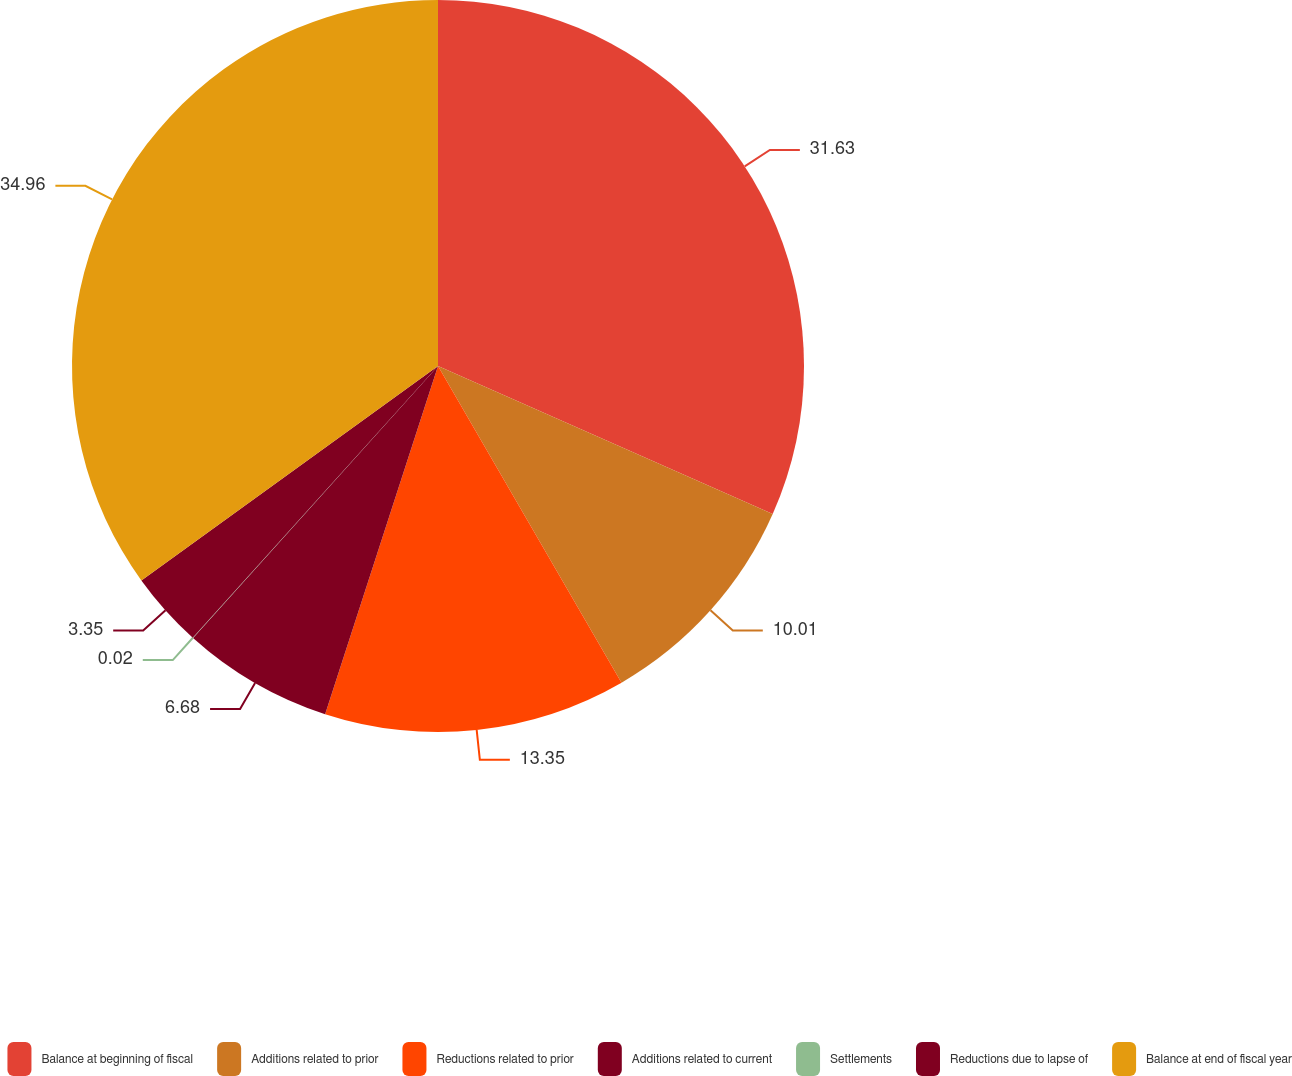Convert chart. <chart><loc_0><loc_0><loc_500><loc_500><pie_chart><fcel>Balance at beginning of fiscal<fcel>Additions related to prior<fcel>Reductions related to prior<fcel>Additions related to current<fcel>Settlements<fcel>Reductions due to lapse of<fcel>Balance at end of fiscal year<nl><fcel>31.63%<fcel>10.01%<fcel>13.35%<fcel>6.68%<fcel>0.02%<fcel>3.35%<fcel>34.96%<nl></chart> 